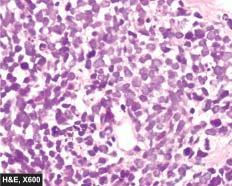re the tumour cells arranged in sheets, cords or aggregates and at places form pseudorosettes?
Answer the question using a single word or phrase. Yes 